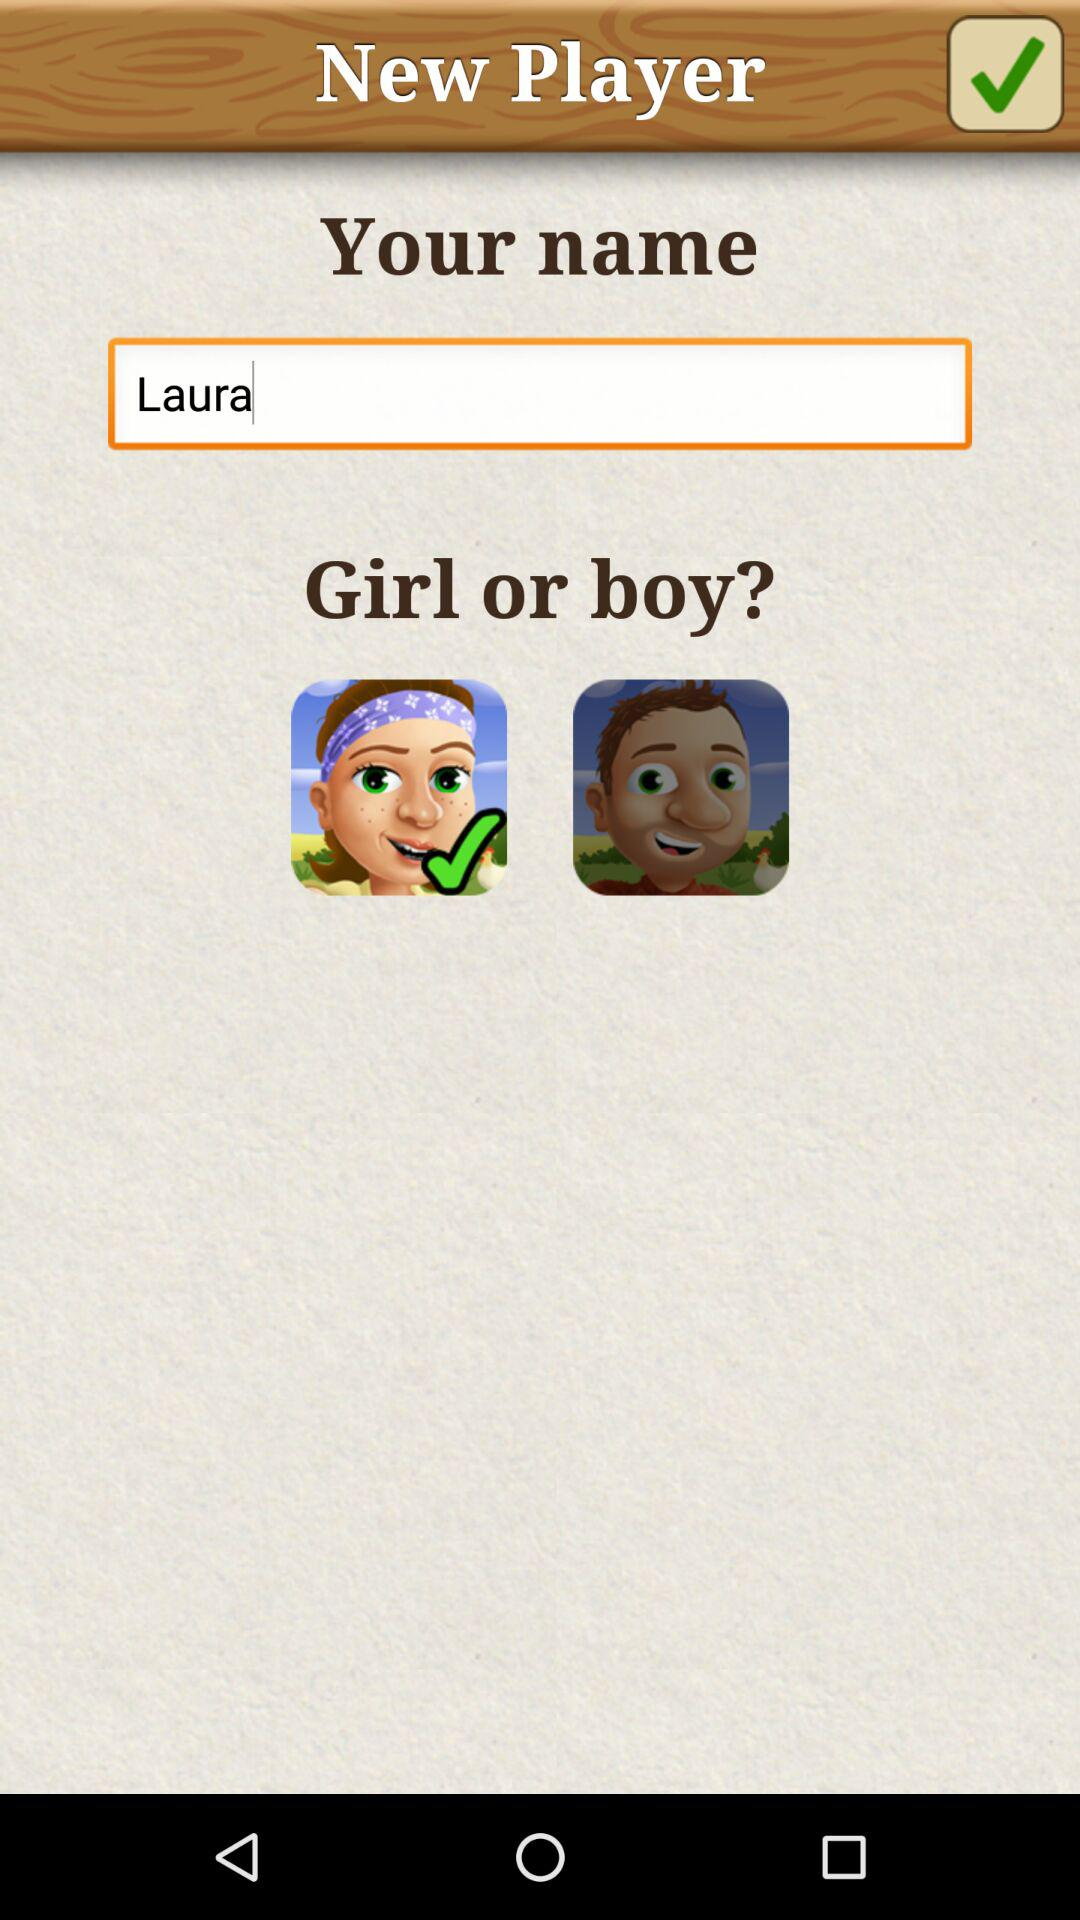What is the name? The name is Laura. 